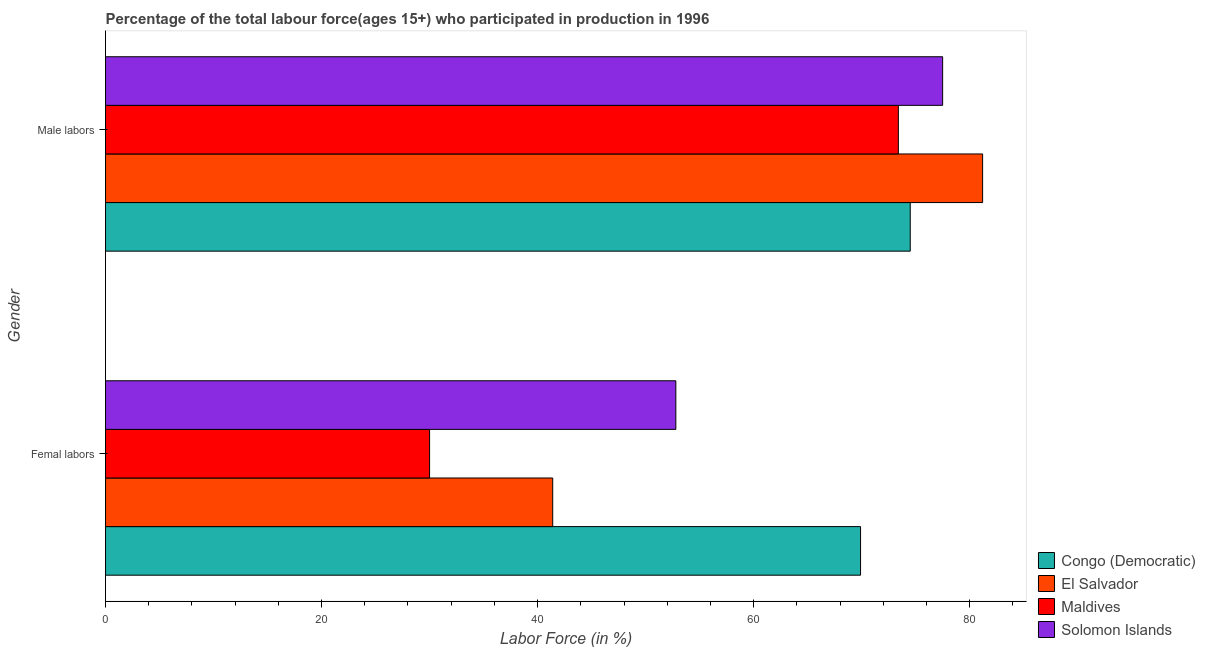How many different coloured bars are there?
Keep it short and to the point. 4. How many bars are there on the 2nd tick from the bottom?
Provide a succinct answer. 4. What is the label of the 2nd group of bars from the top?
Offer a terse response. Femal labors. What is the percentage of male labour force in Maldives?
Offer a terse response. 73.4. Across all countries, what is the maximum percentage of male labour force?
Offer a very short reply. 81.2. In which country was the percentage of male labour force maximum?
Keep it short and to the point. El Salvador. In which country was the percentage of male labour force minimum?
Ensure brevity in your answer.  Maldives. What is the total percentage of female labor force in the graph?
Keep it short and to the point. 194.1. What is the difference between the percentage of male labour force in Congo (Democratic) and that in El Salvador?
Provide a short and direct response. -6.7. What is the difference between the percentage of female labor force in Solomon Islands and the percentage of male labour force in El Salvador?
Your answer should be compact. -28.4. What is the average percentage of female labor force per country?
Your answer should be very brief. 48.53. What is the difference between the percentage of female labor force and percentage of male labour force in Maldives?
Your answer should be very brief. -43.4. In how many countries, is the percentage of female labor force greater than 56 %?
Provide a succinct answer. 1. What is the ratio of the percentage of male labour force in Maldives to that in Congo (Democratic)?
Offer a terse response. 0.99. What does the 4th bar from the top in Femal labors represents?
Provide a short and direct response. Congo (Democratic). What does the 1st bar from the bottom in Male labors represents?
Provide a short and direct response. Congo (Democratic). How many bars are there?
Make the answer very short. 8. Are all the bars in the graph horizontal?
Provide a succinct answer. Yes. What is the difference between two consecutive major ticks on the X-axis?
Your answer should be very brief. 20. Does the graph contain grids?
Your answer should be very brief. No. How many legend labels are there?
Your answer should be compact. 4. What is the title of the graph?
Make the answer very short. Percentage of the total labour force(ages 15+) who participated in production in 1996. Does "Japan" appear as one of the legend labels in the graph?
Keep it short and to the point. No. What is the label or title of the X-axis?
Keep it short and to the point. Labor Force (in %). What is the Labor Force (in %) of Congo (Democratic) in Femal labors?
Make the answer very short. 69.9. What is the Labor Force (in %) in El Salvador in Femal labors?
Your answer should be compact. 41.4. What is the Labor Force (in %) in Solomon Islands in Femal labors?
Give a very brief answer. 52.8. What is the Labor Force (in %) of Congo (Democratic) in Male labors?
Your response must be concise. 74.5. What is the Labor Force (in %) in El Salvador in Male labors?
Your response must be concise. 81.2. What is the Labor Force (in %) of Maldives in Male labors?
Make the answer very short. 73.4. What is the Labor Force (in %) of Solomon Islands in Male labors?
Offer a very short reply. 77.5. Across all Gender, what is the maximum Labor Force (in %) of Congo (Democratic)?
Give a very brief answer. 74.5. Across all Gender, what is the maximum Labor Force (in %) of El Salvador?
Provide a short and direct response. 81.2. Across all Gender, what is the maximum Labor Force (in %) in Maldives?
Provide a succinct answer. 73.4. Across all Gender, what is the maximum Labor Force (in %) of Solomon Islands?
Your response must be concise. 77.5. Across all Gender, what is the minimum Labor Force (in %) in Congo (Democratic)?
Your response must be concise. 69.9. Across all Gender, what is the minimum Labor Force (in %) in El Salvador?
Provide a short and direct response. 41.4. Across all Gender, what is the minimum Labor Force (in %) of Solomon Islands?
Give a very brief answer. 52.8. What is the total Labor Force (in %) in Congo (Democratic) in the graph?
Your response must be concise. 144.4. What is the total Labor Force (in %) of El Salvador in the graph?
Offer a very short reply. 122.6. What is the total Labor Force (in %) of Maldives in the graph?
Your response must be concise. 103.4. What is the total Labor Force (in %) of Solomon Islands in the graph?
Offer a very short reply. 130.3. What is the difference between the Labor Force (in %) in Congo (Democratic) in Femal labors and that in Male labors?
Provide a short and direct response. -4.6. What is the difference between the Labor Force (in %) in El Salvador in Femal labors and that in Male labors?
Ensure brevity in your answer.  -39.8. What is the difference between the Labor Force (in %) in Maldives in Femal labors and that in Male labors?
Provide a short and direct response. -43.4. What is the difference between the Labor Force (in %) of Solomon Islands in Femal labors and that in Male labors?
Your response must be concise. -24.7. What is the difference between the Labor Force (in %) of Congo (Democratic) in Femal labors and the Labor Force (in %) of Maldives in Male labors?
Ensure brevity in your answer.  -3.5. What is the difference between the Labor Force (in %) in Congo (Democratic) in Femal labors and the Labor Force (in %) in Solomon Islands in Male labors?
Offer a very short reply. -7.6. What is the difference between the Labor Force (in %) in El Salvador in Femal labors and the Labor Force (in %) in Maldives in Male labors?
Offer a terse response. -32. What is the difference between the Labor Force (in %) in El Salvador in Femal labors and the Labor Force (in %) in Solomon Islands in Male labors?
Your answer should be compact. -36.1. What is the difference between the Labor Force (in %) of Maldives in Femal labors and the Labor Force (in %) of Solomon Islands in Male labors?
Provide a succinct answer. -47.5. What is the average Labor Force (in %) in Congo (Democratic) per Gender?
Make the answer very short. 72.2. What is the average Labor Force (in %) of El Salvador per Gender?
Provide a short and direct response. 61.3. What is the average Labor Force (in %) in Maldives per Gender?
Provide a short and direct response. 51.7. What is the average Labor Force (in %) in Solomon Islands per Gender?
Keep it short and to the point. 65.15. What is the difference between the Labor Force (in %) in Congo (Democratic) and Labor Force (in %) in El Salvador in Femal labors?
Offer a very short reply. 28.5. What is the difference between the Labor Force (in %) of Congo (Democratic) and Labor Force (in %) of Maldives in Femal labors?
Provide a succinct answer. 39.9. What is the difference between the Labor Force (in %) in El Salvador and Labor Force (in %) in Solomon Islands in Femal labors?
Make the answer very short. -11.4. What is the difference between the Labor Force (in %) in Maldives and Labor Force (in %) in Solomon Islands in Femal labors?
Keep it short and to the point. -22.8. What is the difference between the Labor Force (in %) of Congo (Democratic) and Labor Force (in %) of Maldives in Male labors?
Provide a short and direct response. 1.1. What is the difference between the Labor Force (in %) in El Salvador and Labor Force (in %) in Maldives in Male labors?
Provide a short and direct response. 7.8. What is the difference between the Labor Force (in %) of El Salvador and Labor Force (in %) of Solomon Islands in Male labors?
Keep it short and to the point. 3.7. What is the ratio of the Labor Force (in %) in Congo (Democratic) in Femal labors to that in Male labors?
Provide a succinct answer. 0.94. What is the ratio of the Labor Force (in %) of El Salvador in Femal labors to that in Male labors?
Give a very brief answer. 0.51. What is the ratio of the Labor Force (in %) in Maldives in Femal labors to that in Male labors?
Your response must be concise. 0.41. What is the ratio of the Labor Force (in %) of Solomon Islands in Femal labors to that in Male labors?
Keep it short and to the point. 0.68. What is the difference between the highest and the second highest Labor Force (in %) in Congo (Democratic)?
Your answer should be compact. 4.6. What is the difference between the highest and the second highest Labor Force (in %) in El Salvador?
Offer a very short reply. 39.8. What is the difference between the highest and the second highest Labor Force (in %) in Maldives?
Offer a very short reply. 43.4. What is the difference between the highest and the second highest Labor Force (in %) of Solomon Islands?
Make the answer very short. 24.7. What is the difference between the highest and the lowest Labor Force (in %) of Congo (Democratic)?
Provide a succinct answer. 4.6. What is the difference between the highest and the lowest Labor Force (in %) of El Salvador?
Ensure brevity in your answer.  39.8. What is the difference between the highest and the lowest Labor Force (in %) in Maldives?
Offer a terse response. 43.4. What is the difference between the highest and the lowest Labor Force (in %) of Solomon Islands?
Offer a very short reply. 24.7. 